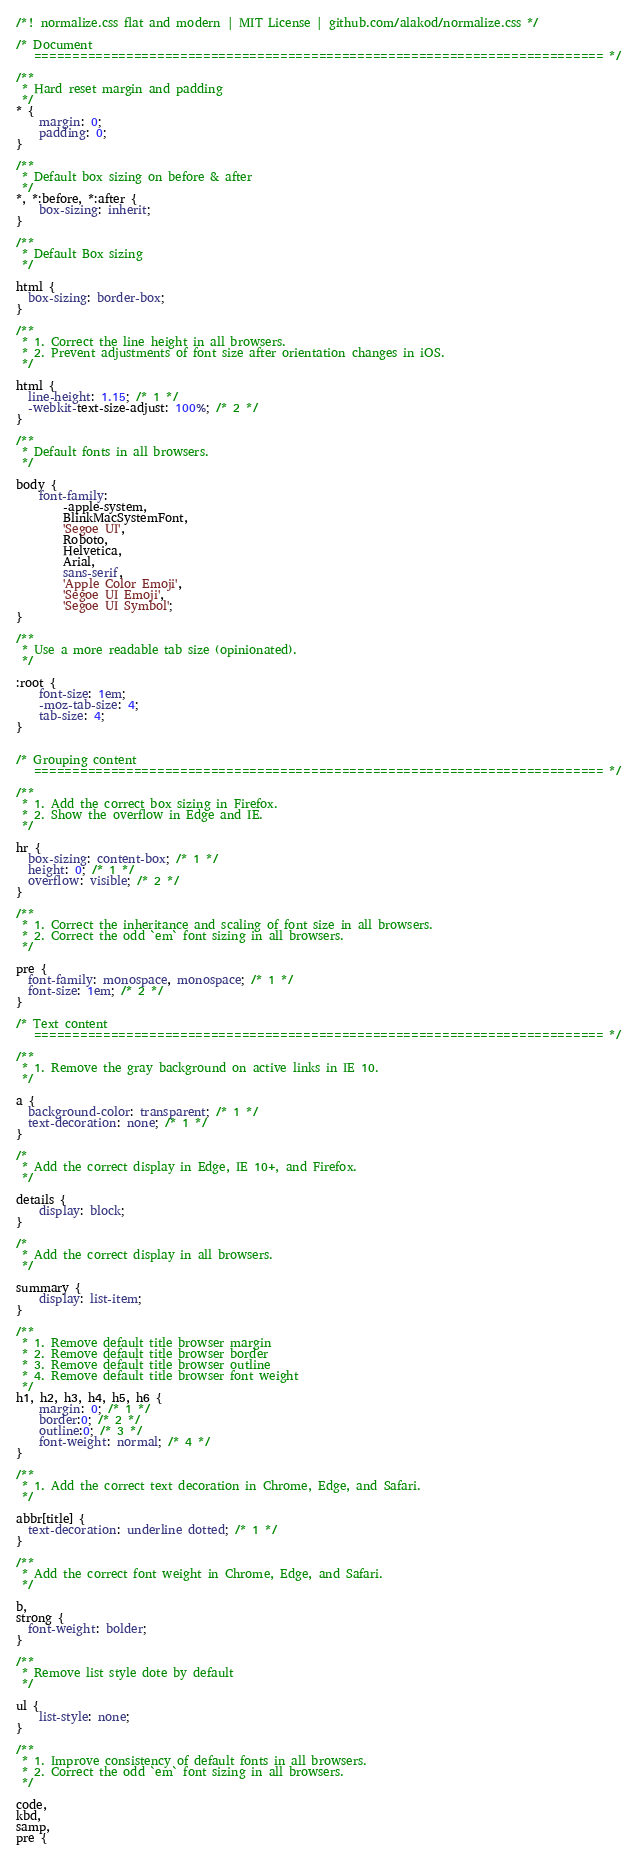Convert code to text. <code><loc_0><loc_0><loc_500><loc_500><_CSS_>/*! normalize.css flat and modern | MIT License | github.com/alakod/normalize.css */

/* Document
   ========================================================================== */

/**
 * Hard reset margin and padding
 */
* {
    margin: 0;
    padding: 0;
}

/**
 * Default box sizing on before & after
 */
*, *:before, *:after {
    box-sizing: inherit;
}

/**
 * Default Box sizing
 */

html {
  box-sizing: border-box;
}

/**
 * 1. Correct the line height in all browsers.
 * 2. Prevent adjustments of font size after orientation changes in iOS.
 */

html {
  line-height: 1.15; /* 1 */
  -webkit-text-size-adjust: 100%; /* 2 */
}

/**
 * Default fonts in all browsers.
 */

body {
	font-family:
		-apple-system,
		BlinkMacSystemFont,
		'Segoe UI',
		Roboto,
		Helvetica,
		Arial,
		sans-serif,
		'Apple Color Emoji',
		'Segoe UI Emoji',
		'Segoe UI Symbol';
}

/**
 * Use a more readable tab size (opinionated).
 */

:root {
	font-size: 1em;
	-moz-tab-size: 4;
	tab-size: 4;
}


/* Grouping content
   ========================================================================== */

/**
 * 1. Add the correct box sizing in Firefox.
 * 2. Show the overflow in Edge and IE.
 */

hr {
  box-sizing: content-box; /* 1 */
  height: 0; /* 1 */
  overflow: visible; /* 2 */
}

/**
 * 1. Correct the inheritance and scaling of font size in all browsers.
 * 2. Correct the odd `em` font sizing in all browsers.
 */

pre {
  font-family: monospace, monospace; /* 1 */
  font-size: 1em; /* 2 */
}

/* Text content
   ========================================================================== */

/**
 * 1. Remove the gray background on active links in IE 10.
 */

a {
  background-color: transparent; /* 1 */
  text-decoration: none; /* 1 */
}

/*
 * Add the correct display in Edge, IE 10+, and Firefox.
 */

details {
    display: block;
}

/*
 * Add the correct display in all browsers.
 */

summary {
    display: list-item;
}

/**
 * 1. Remove default title browser margin
 * 2. Remove default title browser border
 * 3. Remove default title browser outline
 * 4. Remove default title browser font weight
 */
h1, h2, h3, h4, h5, h6 {
    margin: 0; /* 1 */
    border:0; /* 2 */
    outline:0; /* 3 */
    font-weight: normal; /* 4 */
}

/**
 * 1. Add the correct text decoration in Chrome, Edge, and Safari.
 */

abbr[title] {
  text-decoration: underline dotted; /* 1 */
}

/**
 * Add the correct font weight in Chrome, Edge, and Safari.
 */

b,
strong {
  font-weight: bolder;
}

/**
 * Remove list style dote by default
 */

ul {
    list-style: none;
}

/**
 * 1. Improve consistency of default fonts in all browsers. 
 * 2. Correct the odd `em` font sizing in all browsers.
 */

code,
kbd,
samp,
pre {</code> 